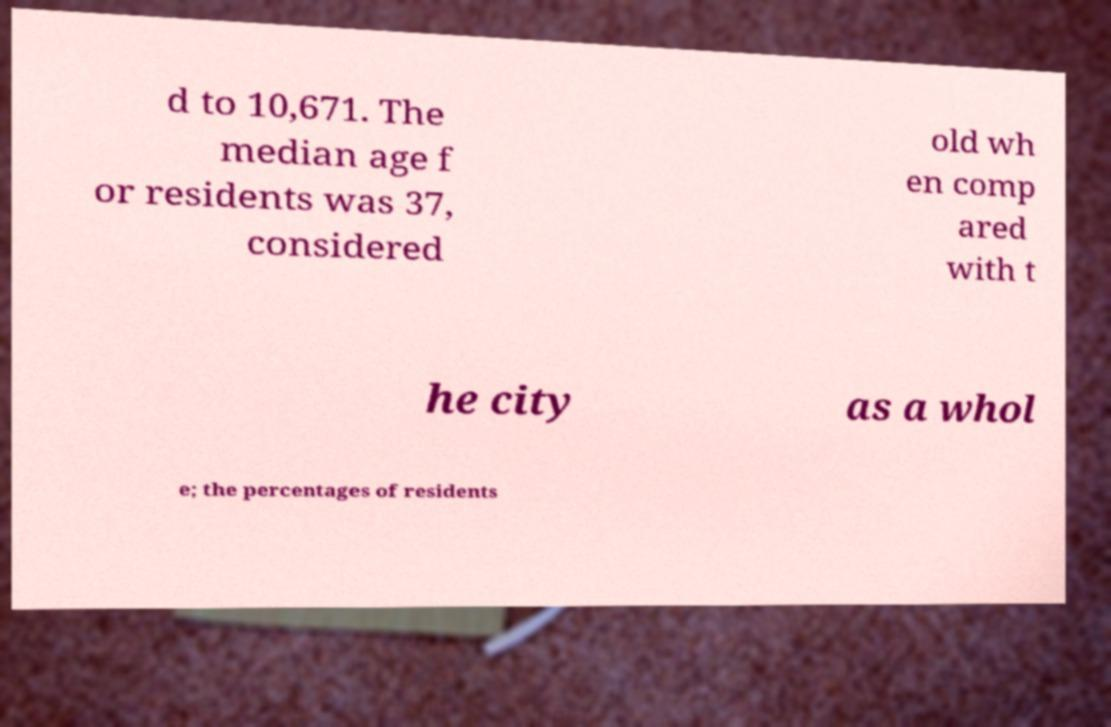Could you extract and type out the text from this image? d to 10,671. The median age f or residents was 37, considered old wh en comp ared with t he city as a whol e; the percentages of residents 